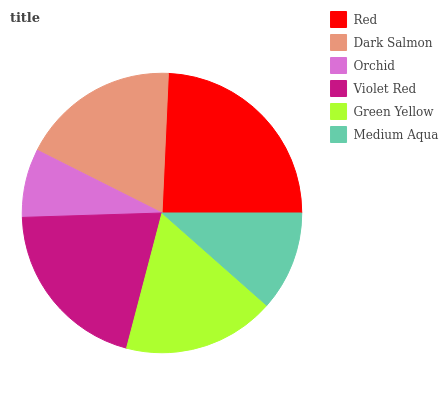Is Orchid the minimum?
Answer yes or no. Yes. Is Red the maximum?
Answer yes or no. Yes. Is Dark Salmon the minimum?
Answer yes or no. No. Is Dark Salmon the maximum?
Answer yes or no. No. Is Red greater than Dark Salmon?
Answer yes or no. Yes. Is Dark Salmon less than Red?
Answer yes or no. Yes. Is Dark Salmon greater than Red?
Answer yes or no. No. Is Red less than Dark Salmon?
Answer yes or no. No. Is Dark Salmon the high median?
Answer yes or no. Yes. Is Green Yellow the low median?
Answer yes or no. Yes. Is Violet Red the high median?
Answer yes or no. No. Is Medium Aqua the low median?
Answer yes or no. No. 